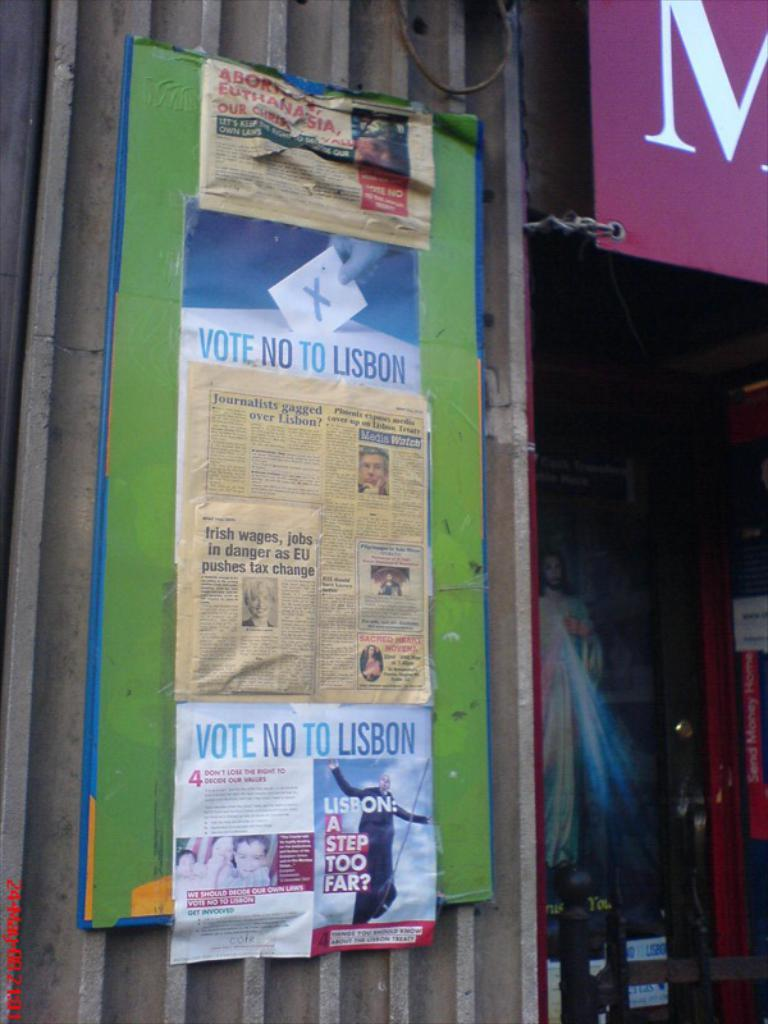<image>
Give a short and clear explanation of the subsequent image. A flyer that says Vote No to Lisbon. 